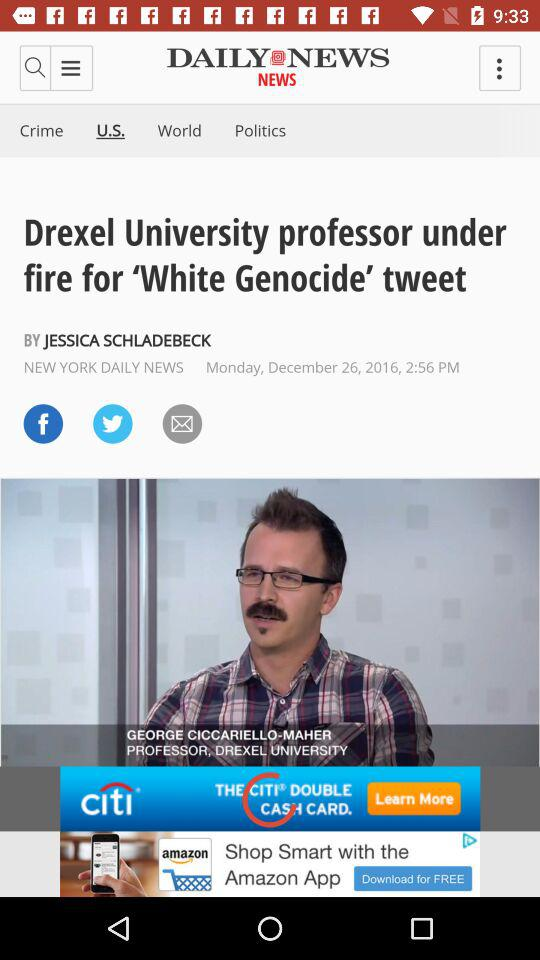Who published the news about "Drexel University"? The news was published by "NEW YORK DAILY NEWS". 